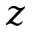Convert formula to latex. <formula><loc_0><loc_0><loc_500><loc_500>z</formula> 